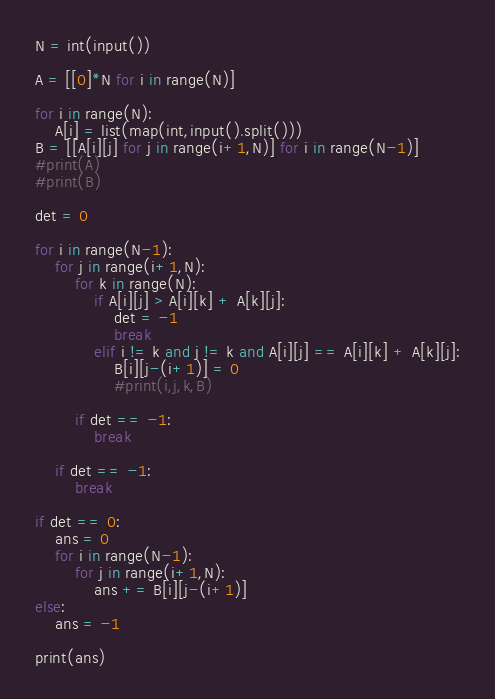<code> <loc_0><loc_0><loc_500><loc_500><_Python_>N = int(input())

A = [[0]*N for i in range(N)]

for i in range(N):
    A[i] = list(map(int,input().split()))
B = [[A[i][j] for j in range(i+1,N)] for i in range(N-1)]
#print(A)
#print(B)

det = 0

for i in range(N-1):
    for j in range(i+1,N):
        for k in range(N):
            if A[i][j] > A[i][k] + A[k][j]:
                det = -1
                break
            elif i != k and j != k and A[i][j] == A[i][k] + A[k][j]:
                B[i][j-(i+1)] = 0
                #print(i,j,k,B)
        
        if det == -1:
            break

    if det == -1:
        break

if det == 0:
    ans = 0
    for i in range(N-1):
        for j in range(i+1,N):
            ans += B[i][j-(i+1)]
else:
    ans = -1

print(ans)
</code> 